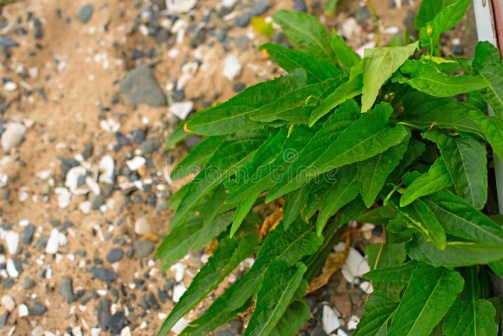What's happening in the scene? The scene captures a moment of tranquility in nature, highlighting the beauty of natural elements. A green plant with long, slender leaves is prominently featured in the bottom right corner, nestled among an array of small rocks and pebbles that signify a rugged landscape. In the background, which is softly out of focus, there appears to be a dirt path, suggesting that the plant might be part of a larger natural setting, such as a hillside or a trail area. The composition of the image, with earth tones contrasted by the vibrant green of the plant, evokes a sense of serene wilderness and the intertwined beauty of life and rugged terrain. 